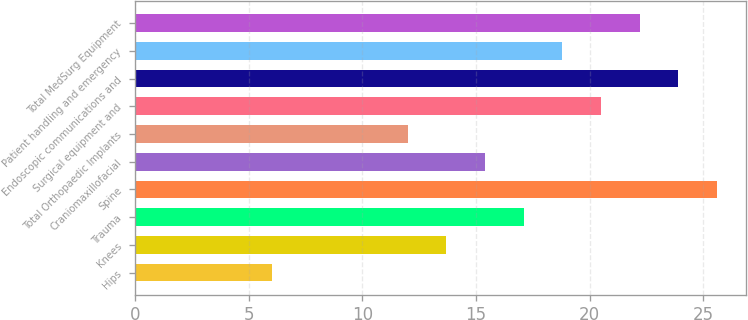<chart> <loc_0><loc_0><loc_500><loc_500><bar_chart><fcel>Hips<fcel>Knees<fcel>Trauma<fcel>Spine<fcel>Craniomaxillofacial<fcel>Total Orthopaedic Implants<fcel>Surgical equipment and<fcel>Endoscopic communications and<fcel>Patient handling and emergency<fcel>Total MedSurg Equipment<nl><fcel>6<fcel>13.7<fcel>17.1<fcel>25.6<fcel>15.4<fcel>12<fcel>20.5<fcel>23.9<fcel>18.8<fcel>22.2<nl></chart> 